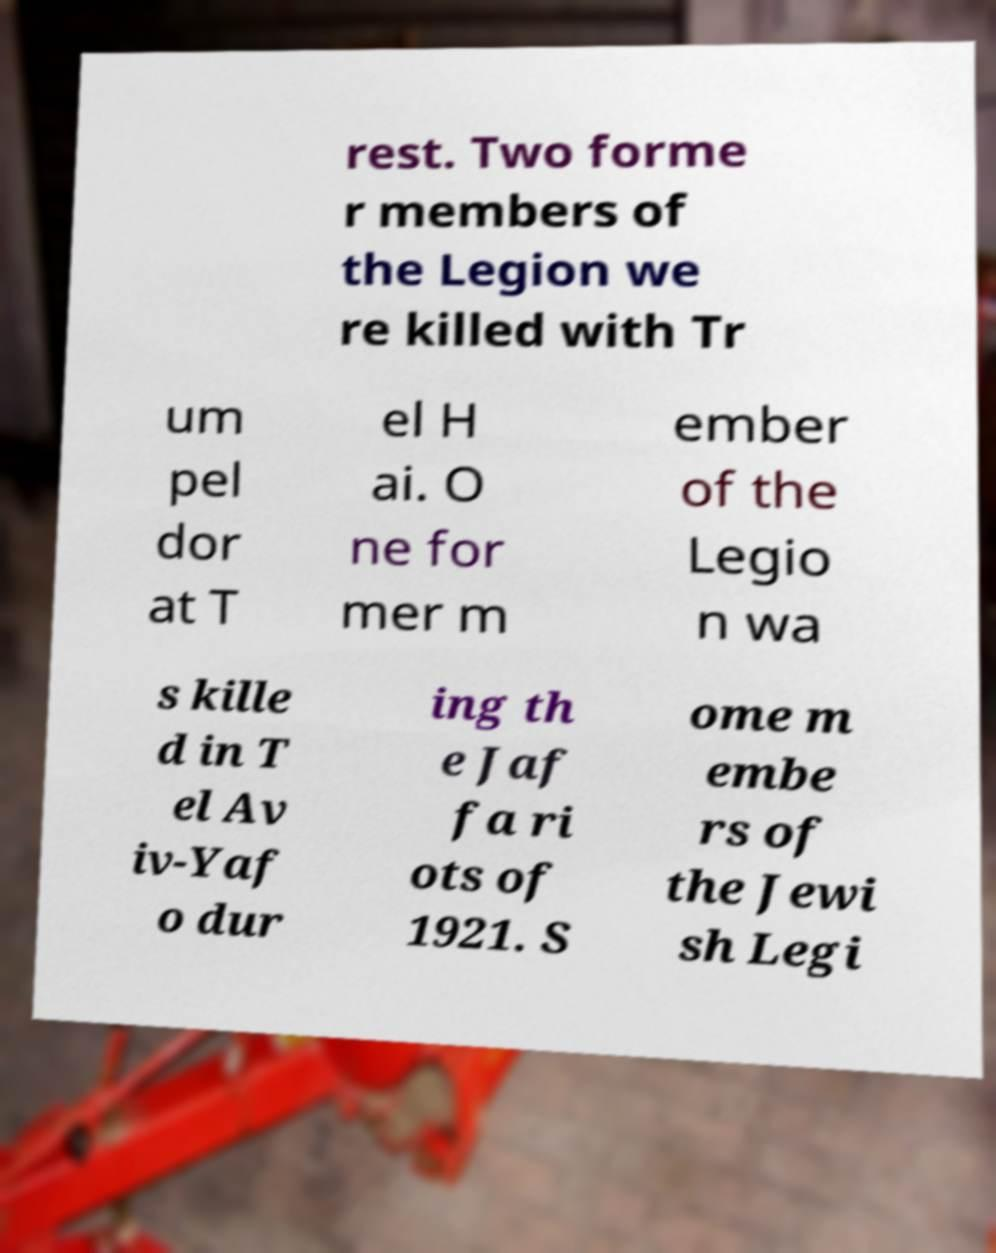Please identify and transcribe the text found in this image. rest. Two forme r members of the Legion we re killed with Tr um pel dor at T el H ai. O ne for mer m ember of the Legio n wa s kille d in T el Av iv-Yaf o dur ing th e Jaf fa ri ots of 1921. S ome m embe rs of the Jewi sh Legi 